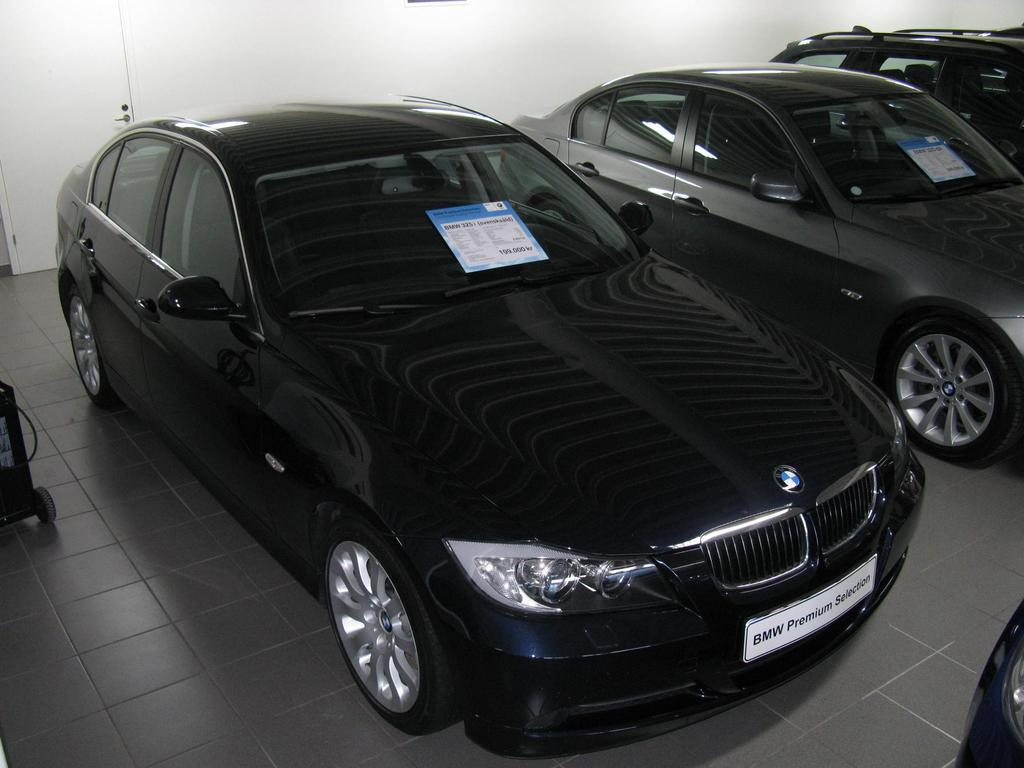What is the main subject of the image? The main subject of the image is cars inside a building. Can you describe any other objects or features in the image? Yes, there is an object with wheels on the floor, and there is a wall in the background of the image. What type of list can be seen hanging on the wall in the image? There is no list present in the image; the wall is mentioned as a background feature, but no specific details about it are provided. 